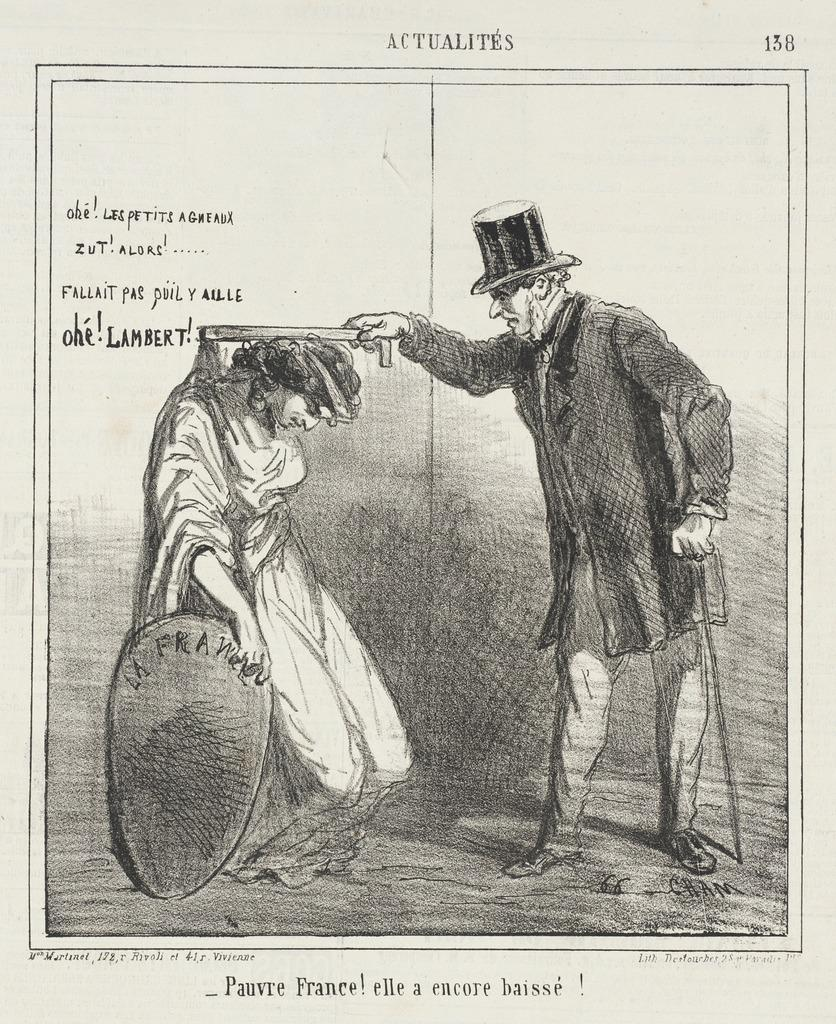What is depicted in the image? There is a picture of two people in the image. Can you describe any additional elements in the image? There is a page with a quotation on the left side of the image. What type of beetle can be seen crawling on the page with the quotation? There is no beetle present in the image. What request is being made by the two people in the image? The image does not depict a request being made by the two people; it only shows their picture. 